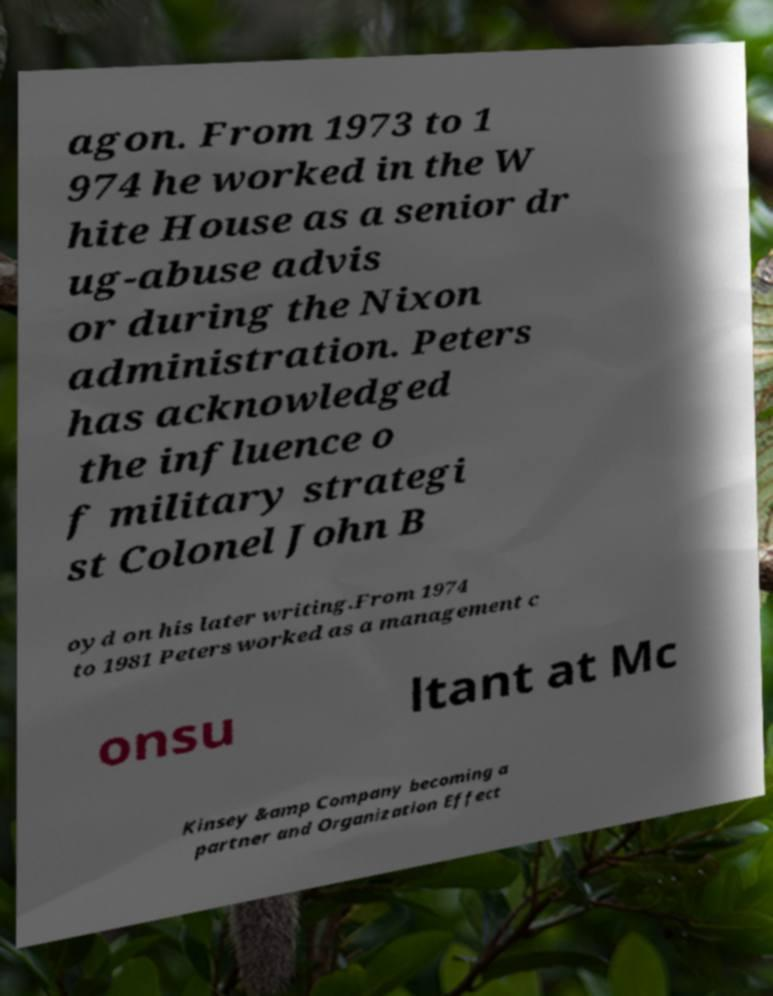Please read and relay the text visible in this image. What does it say? agon. From 1973 to 1 974 he worked in the W hite House as a senior dr ug-abuse advis or during the Nixon administration. Peters has acknowledged the influence o f military strategi st Colonel John B oyd on his later writing.From 1974 to 1981 Peters worked as a management c onsu ltant at Mc Kinsey &amp Company becoming a partner and Organization Effect 